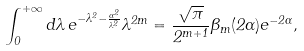<formula> <loc_0><loc_0><loc_500><loc_500>\int _ { 0 } ^ { + \infty } d \lambda \, e ^ { - \lambda ^ { 2 } - \frac { \alpha ^ { 2 } } { \lambda ^ { 2 } } } \lambda ^ { 2 m } = \frac { \sqrt { \pi } } { 2 ^ { m + 1 } } \Theta _ { m } ( 2 \alpha ) e ^ { - 2 \alpha } ,</formula> 